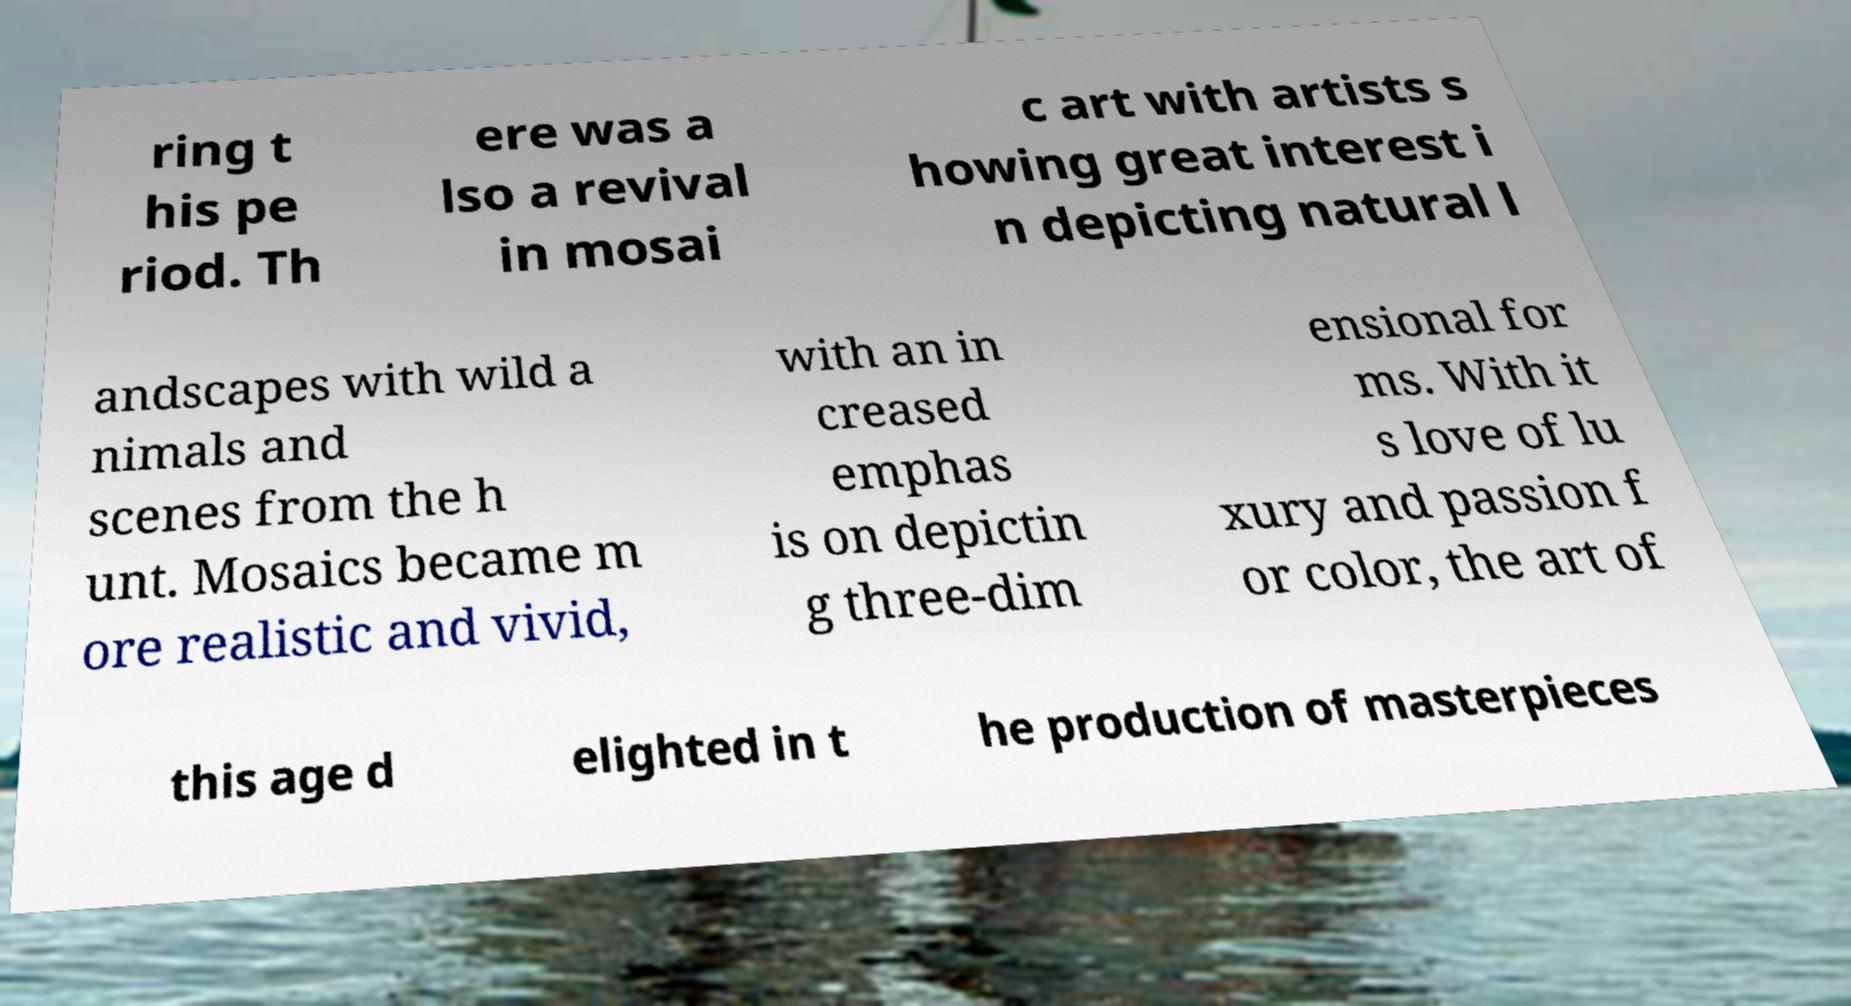Can you read and provide the text displayed in the image?This photo seems to have some interesting text. Can you extract and type it out for me? ring t his pe riod. Th ere was a lso a revival in mosai c art with artists s howing great interest i n depicting natural l andscapes with wild a nimals and scenes from the h unt. Mosaics became m ore realistic and vivid, with an in creased emphas is on depictin g three-dim ensional for ms. With it s love of lu xury and passion f or color, the art of this age d elighted in t he production of masterpieces 